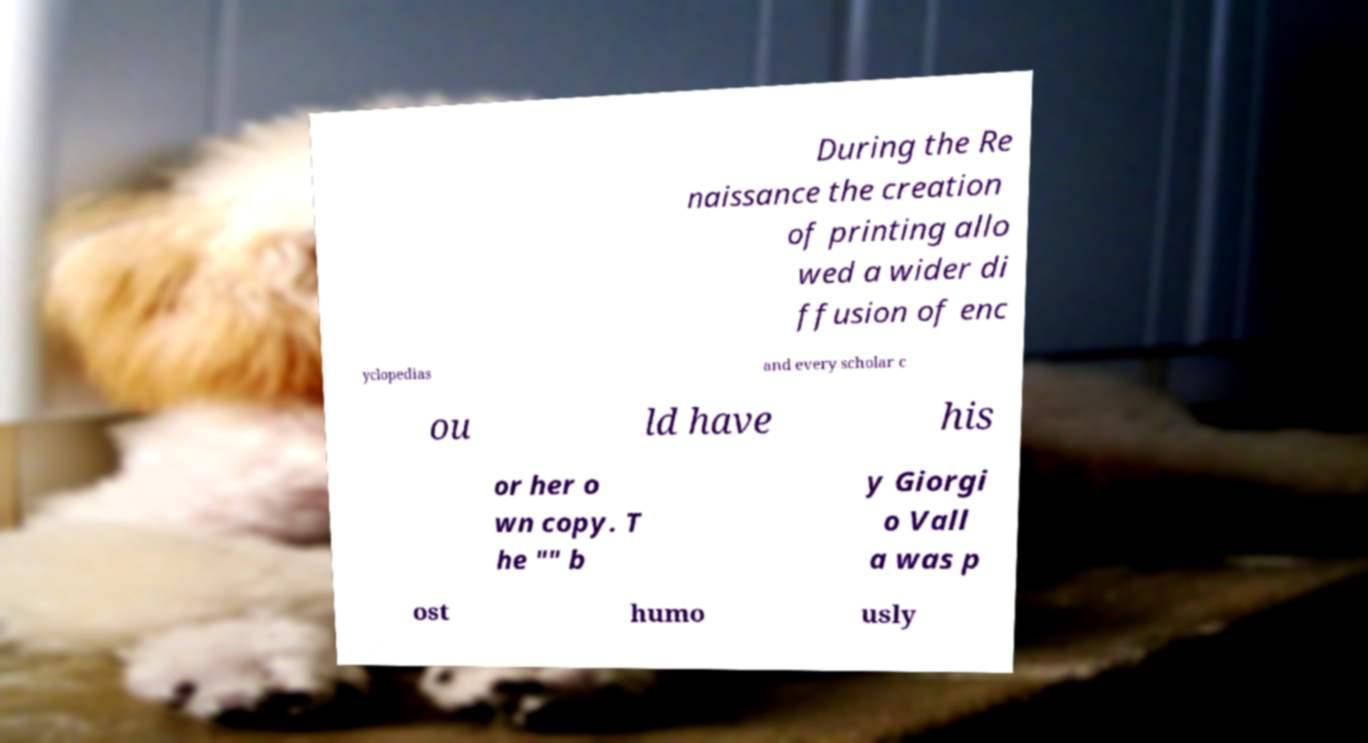What messages or text are displayed in this image? I need them in a readable, typed format. During the Re naissance the creation of printing allo wed a wider di ffusion of enc yclopedias and every scholar c ou ld have his or her o wn copy. T he "" b y Giorgi o Vall a was p ost humo usly 